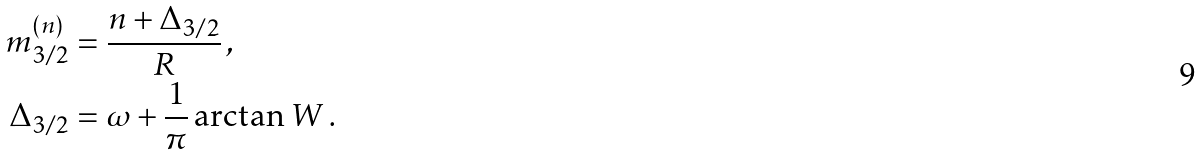<formula> <loc_0><loc_0><loc_500><loc_500>m _ { 3 / 2 } ^ { ( n ) } & = \frac { n + \Delta _ { 3 / 2 } } { R } \, , \\ \Delta _ { 3 / 2 } & = \omega + \frac { 1 } { \pi } \arctan W \, .</formula> 